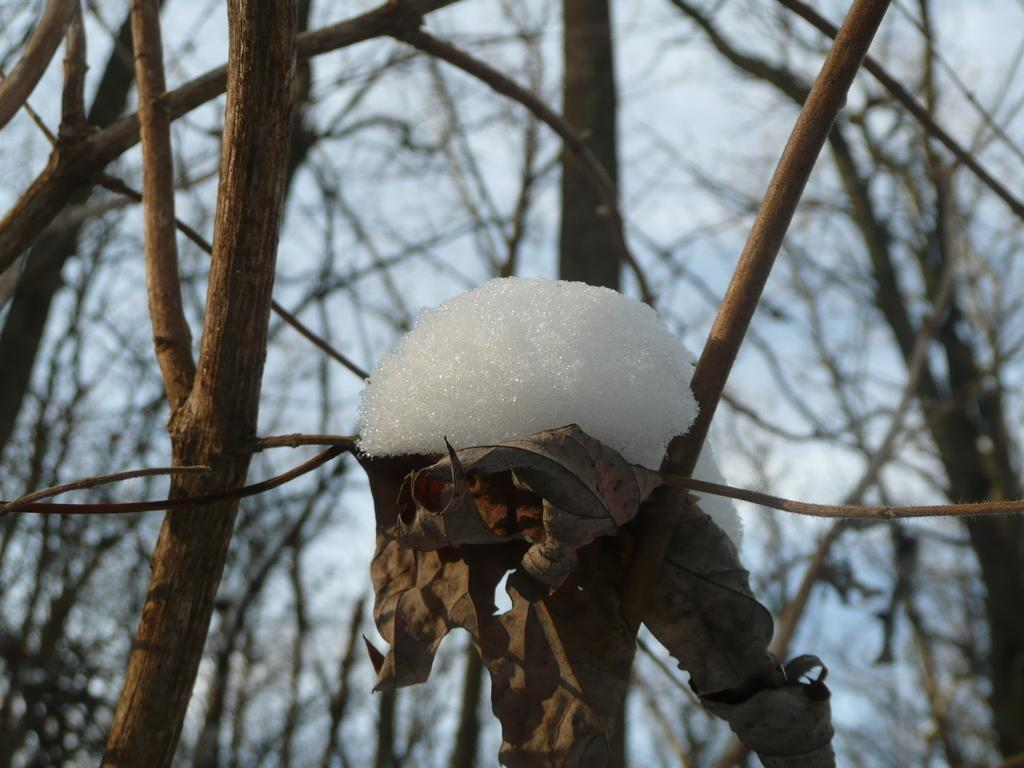What is the main subject of the image? There is a tree in the image. What is a notable feature of the tree? The tree has snow on it. What can be seen in the background of the image? There are dried trees visible in the background of the image, and the sky is also visible. What type of juice is being served by the tree's brother in the image? There is no mention of a brother or juice in the image; it features a tree with snow on it and a background with dried trees and the sky. 